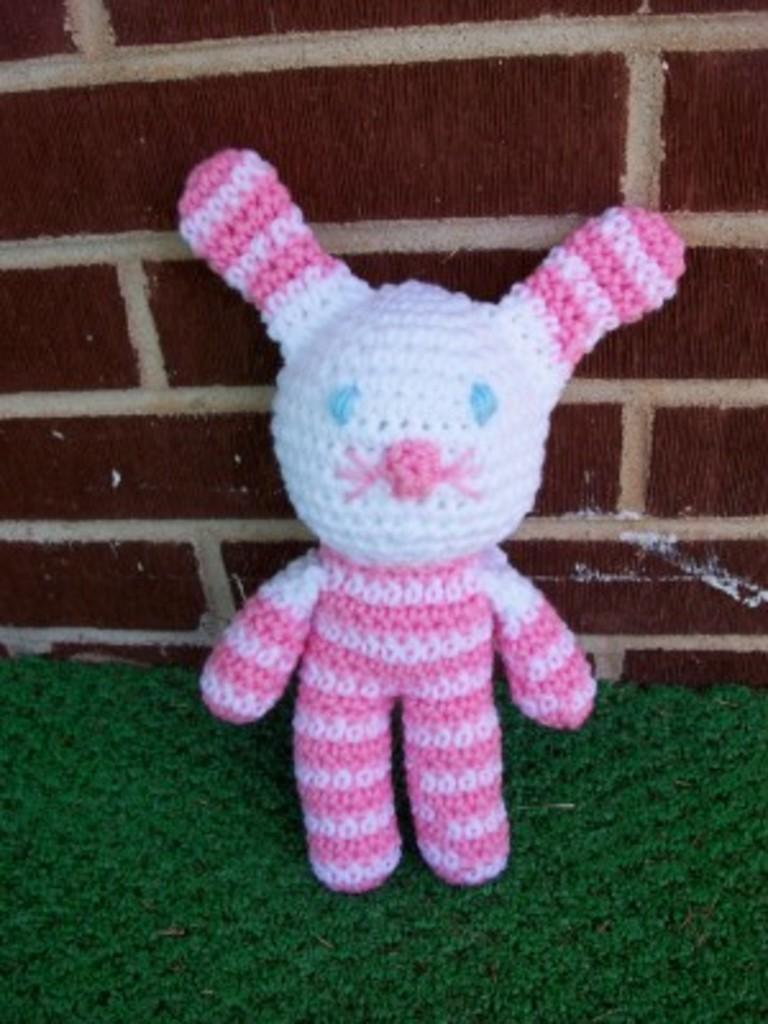What object can be seen in the image that is meant for play or entertainment? There is a toy in the image. What color is the mat that is visible in the image? The mat is green in color. What type of structure can be seen in the image? There is a wall in the image. Where is the bottle located in the image? There is no bottle present in the image. What type of division can be seen in the image? There is no division or separation depicted in the image. 